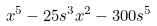Convert formula to latex. <formula><loc_0><loc_0><loc_500><loc_500>x ^ { 5 } - 2 5 s ^ { 3 } x ^ { 2 } - 3 0 0 s ^ { 5 }</formula> 